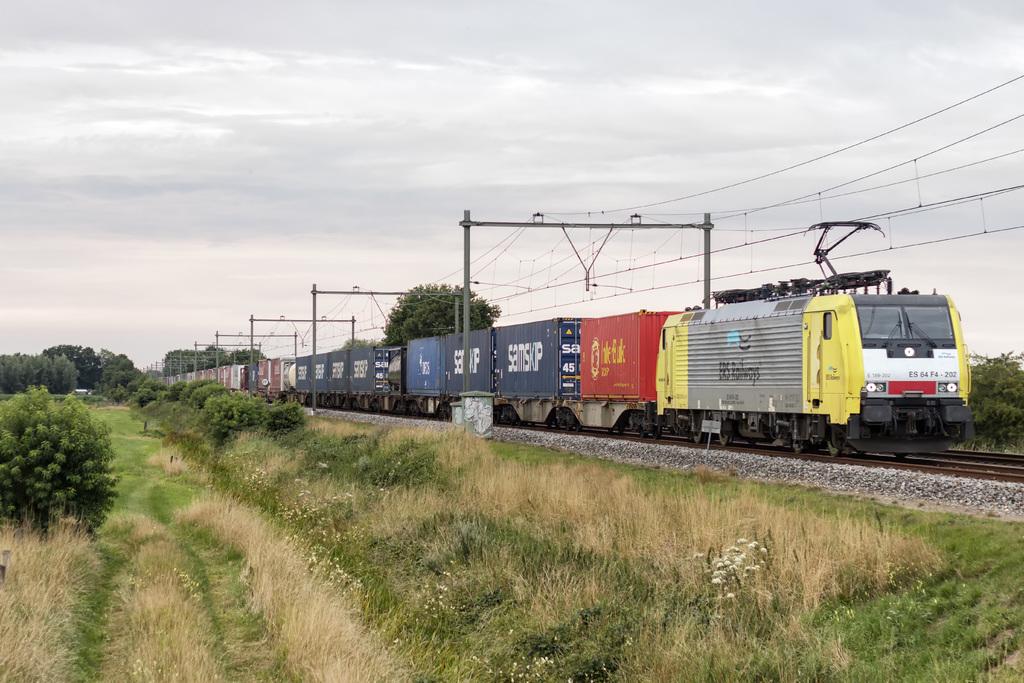What is on the blue car?
Provide a succinct answer. Samskp. 